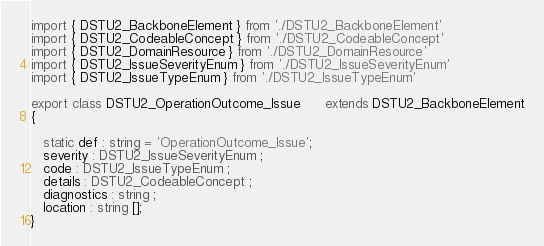Convert code to text. <code><loc_0><loc_0><loc_500><loc_500><_TypeScript_>import { DSTU2_BackboneElement } from './DSTU2_BackboneElement'
import { DSTU2_CodeableConcept } from './DSTU2_CodeableConcept'
import { DSTU2_DomainResource } from './DSTU2_DomainResource'
import { DSTU2_IssueSeverityEnum } from './DSTU2_IssueSeverityEnum'
import { DSTU2_IssueTypeEnum } from './DSTU2_IssueTypeEnum'

export class DSTU2_OperationOutcome_Issue      extends DSTU2_BackboneElement
{

   static def : string = 'OperationOutcome_Issue';
   severity : DSTU2_IssueSeverityEnum ;
   code : DSTU2_IssueTypeEnum ;
   details : DSTU2_CodeableConcept ;
   diagnostics : string ;
   location : string [];
}
</code> 